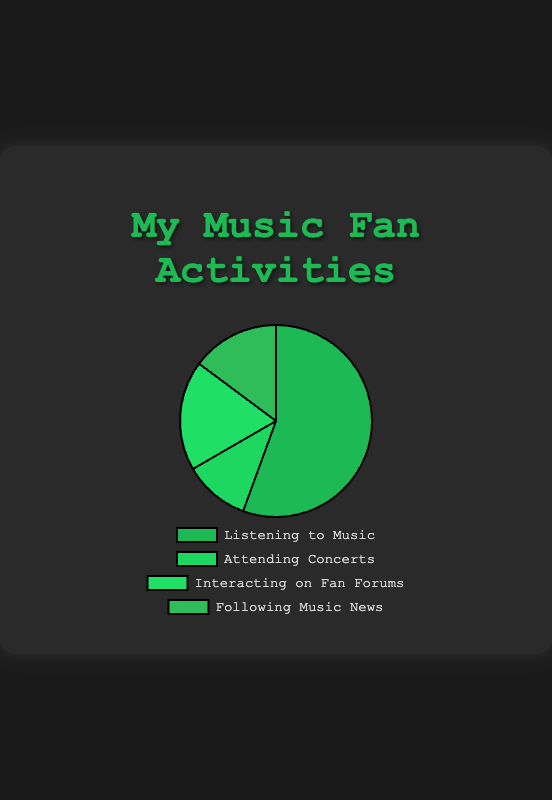What activity do you spend the most time on? The largest portion of the pie chart represents "Listening to Music" with 15 hours per week, which is the highest compared to the other activities.
Answer: Listening to Music Which activity takes up the least amount of your time? The smallest section of the pie chart corresponds to "Attending Concerts," which accounts for 3 hours per week, the lowest time spent among the activities.
Answer: Attending Concerts How many total hours per week do you spend on music-related activities? By adding up all the hours: 15 (Listening to Music) + 3 (Attending Concerts) + 5 (Interacting on Fan Forums) + 4 (Following Music News) = 27 hours per week.
Answer: 27 hours per week What is the combined time spent on interacting on fan forums and following music news? Adding the hours spent on "Interacting on Fan Forums" (5) and "Following Music News" (4) gives a total of 5 + 4 = 9 hours per week.
Answer: 9 hours per week Which two activities combined take up as much time as listening to music alone? "Interacting on Fan Forums" (5 hours) and "Following Music News" (4 hours) together sum to 5 + 4 = 9 hours per week, which is not enough. But adding "Attending Concerts" (3 hours) gives 5 + 4 + 3 = 12 hours, still less than 15. So no two activities combined equal the time spent on "Listening to Music."
Answer: None Compare the time spent on attending concerts with following music news. Which one is greater, and by how much? "Following Music News" accounts for 4 hours per week, which is greater than "Attending Concerts" at 3 hours per week. The difference is 4 - 3 = 1 hour.
Answer: Following Music News, by 1 hour What fraction of the total time is spent on interacting on fan forums? The time spent on interacting on fan forums is 5 hours per week out of a total of 27 hours. The fraction is 5/27. Simplified, it is roughly 0.185, or approximately 18.5%.
Answer: 18.5% What percentage of your music-related activities is spent on listening to music? The time spent on listening to music is 15 hours out of a total of 27 hours. The percentage is (15/27) * 100 = approximately 55.6%.
Answer: 55.6% 